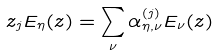<formula> <loc_0><loc_0><loc_500><loc_500>z _ { j } E _ { \eta } ( z ) = \sum _ { \nu } \alpha _ { \eta , \nu } ^ { ( j ) } E _ { \nu } ( z )</formula> 